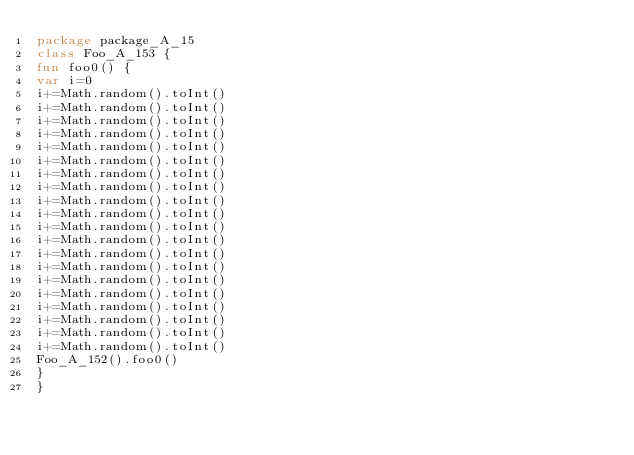<code> <loc_0><loc_0><loc_500><loc_500><_Kotlin_>package package_A_15
class Foo_A_153 {
fun foo0() {
var i=0
i+=Math.random().toInt()
i+=Math.random().toInt()
i+=Math.random().toInt()
i+=Math.random().toInt()
i+=Math.random().toInt()
i+=Math.random().toInt()
i+=Math.random().toInt()
i+=Math.random().toInt()
i+=Math.random().toInt()
i+=Math.random().toInt()
i+=Math.random().toInt()
i+=Math.random().toInt()
i+=Math.random().toInt()
i+=Math.random().toInt()
i+=Math.random().toInt()
i+=Math.random().toInt()
i+=Math.random().toInt()
i+=Math.random().toInt()
i+=Math.random().toInt()
i+=Math.random().toInt()
Foo_A_152().foo0()
}
}</code> 